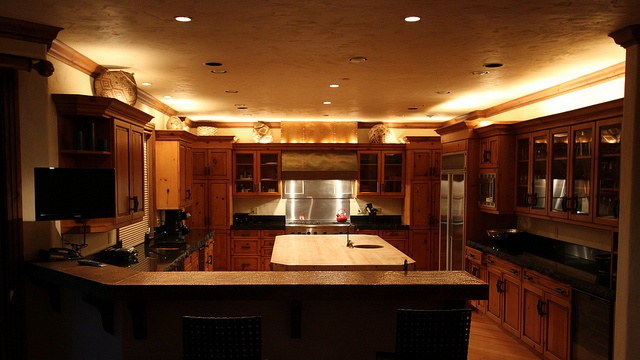Describe the objects in this image and their specific colors. I can see dining table in black, tan, and maroon tones, tv in black, maroon, and olive tones, chair in black, maroon, and brown tones, chair in black, maroon, and gray tones, and refrigerator in black, maroon, and brown tones in this image. 